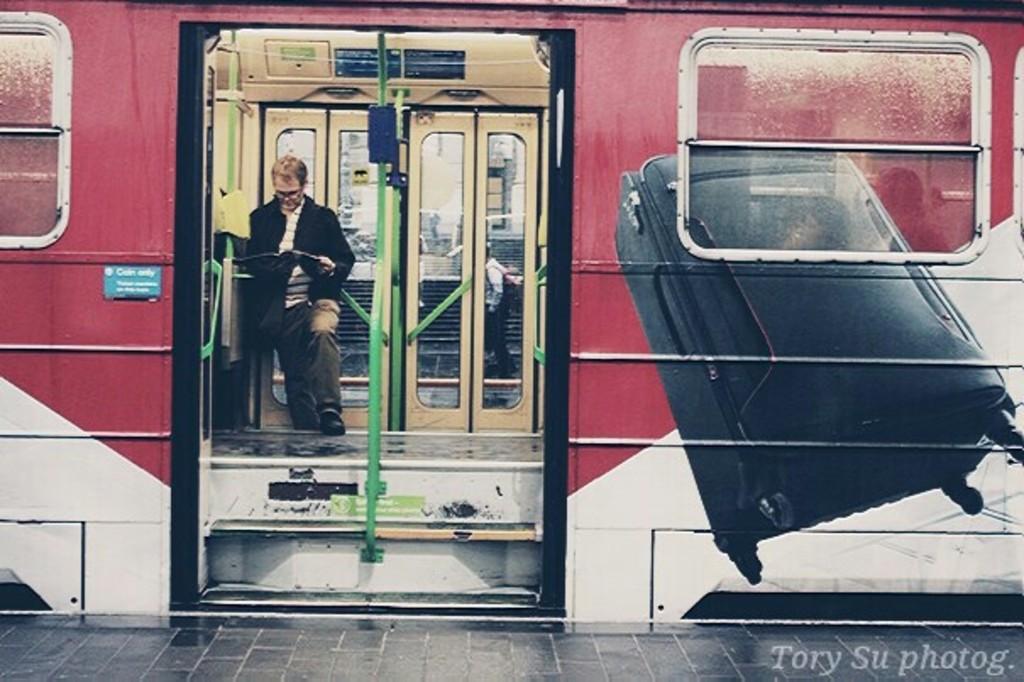Describe this image in one or two sentences. In this image in front there is a train and inside the train there is a person standing by holding the book. In front of the train there is a platform. 